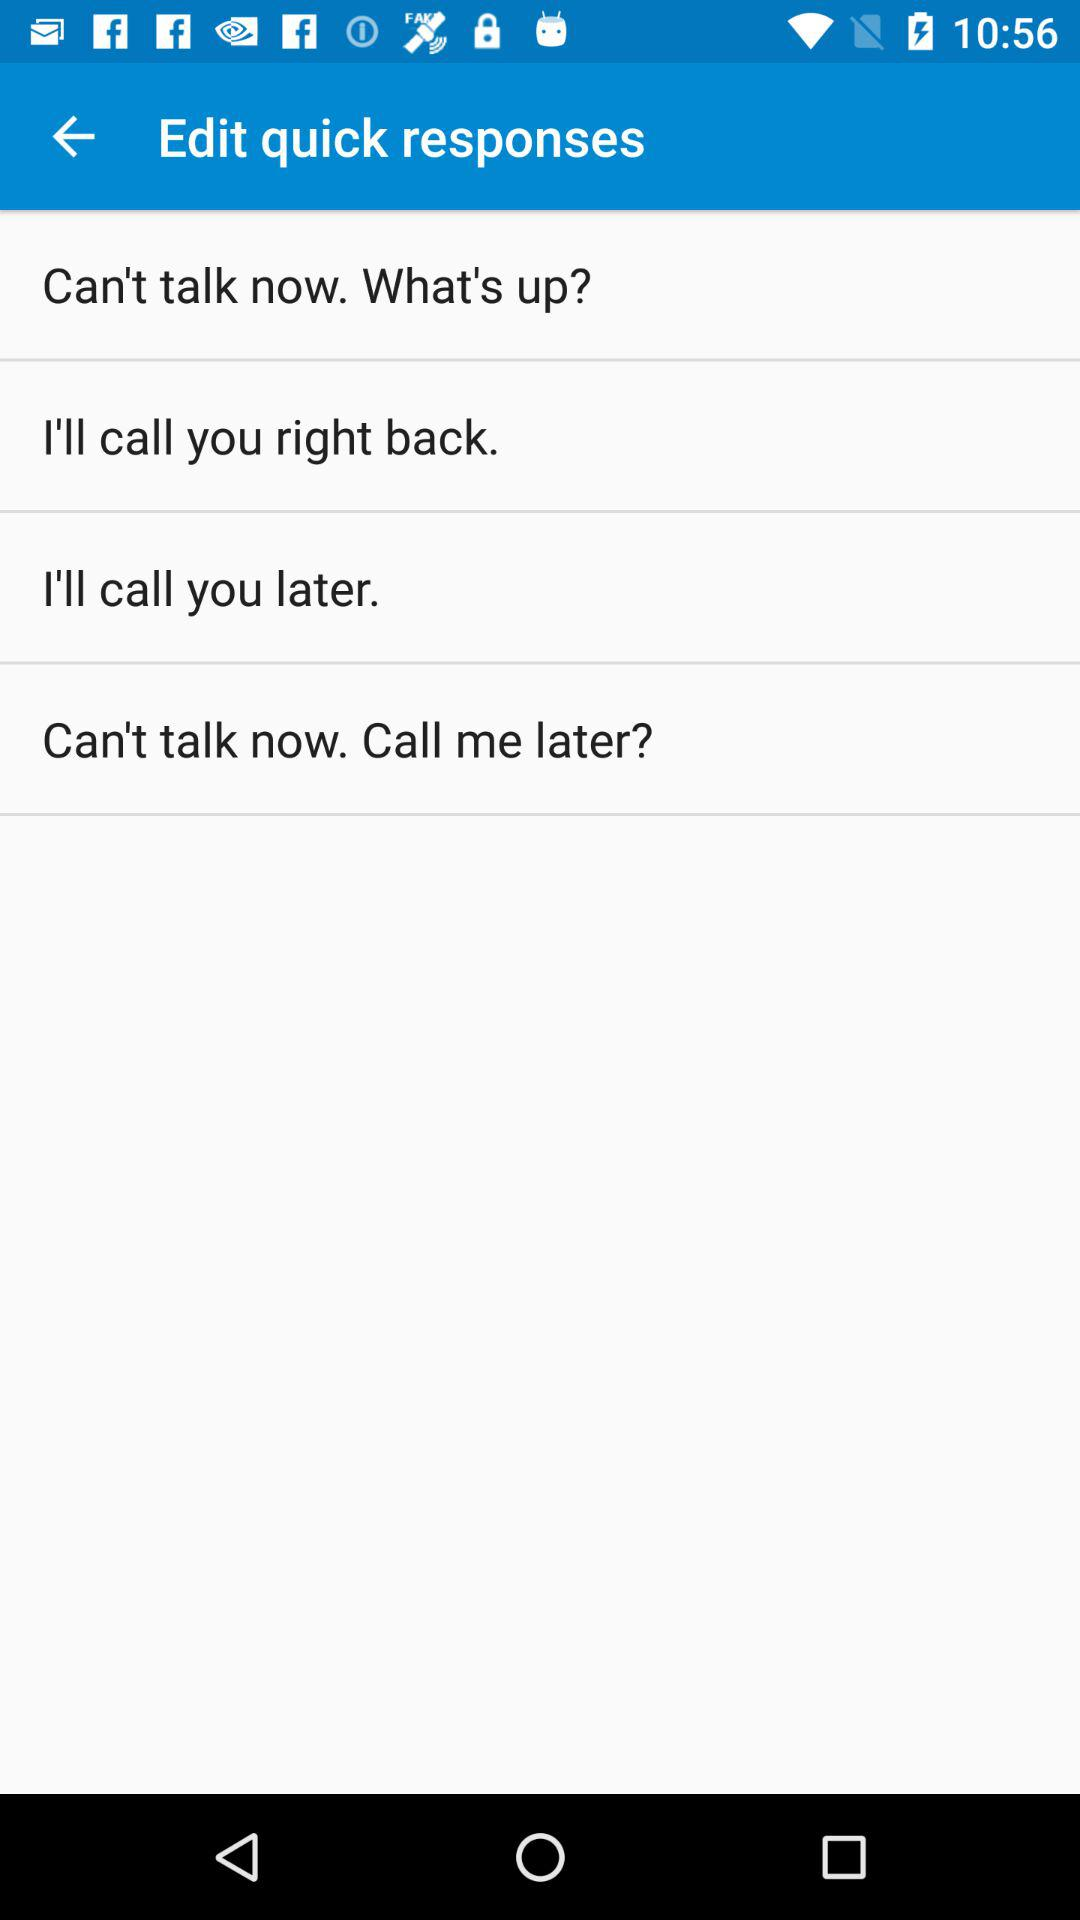How many quick responses are there?
Answer the question using a single word or phrase. 4 